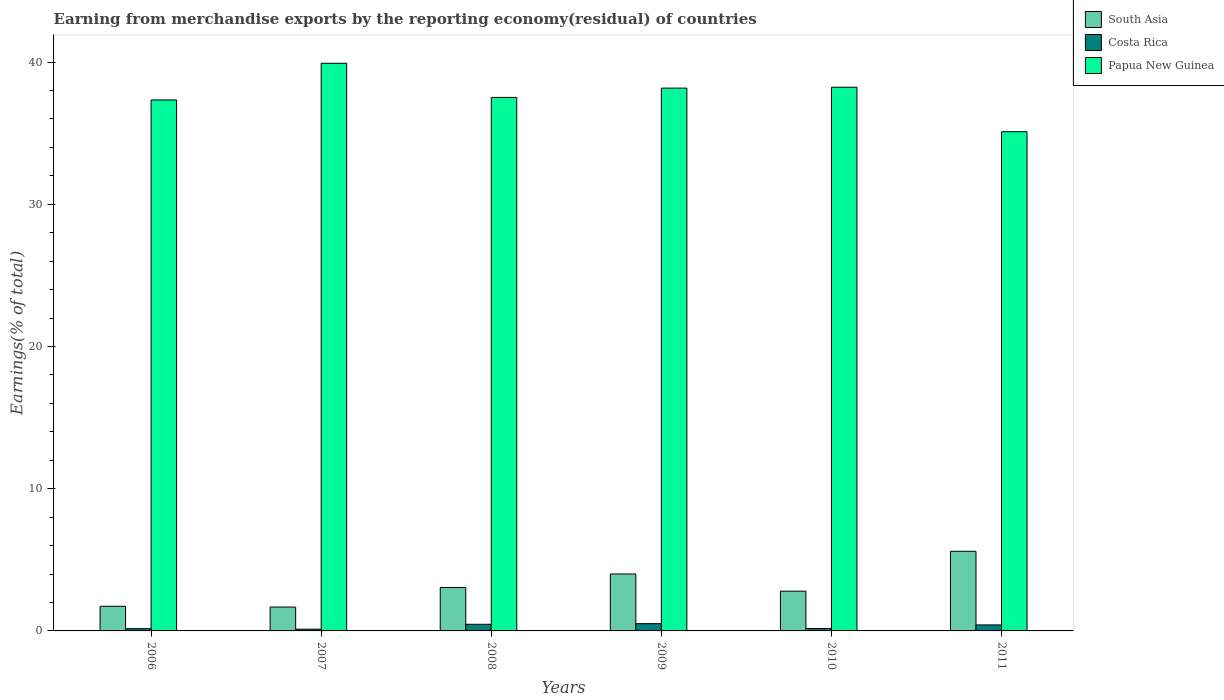How many different coloured bars are there?
Your answer should be very brief. 3. Are the number of bars per tick equal to the number of legend labels?
Your response must be concise. Yes. What is the label of the 3rd group of bars from the left?
Keep it short and to the point. 2008. What is the percentage of amount earned from merchandise exports in Costa Rica in 2006?
Ensure brevity in your answer.  0.16. Across all years, what is the maximum percentage of amount earned from merchandise exports in Costa Rica?
Your answer should be very brief. 0.51. Across all years, what is the minimum percentage of amount earned from merchandise exports in Papua New Guinea?
Provide a succinct answer. 35.1. In which year was the percentage of amount earned from merchandise exports in South Asia maximum?
Offer a very short reply. 2011. In which year was the percentage of amount earned from merchandise exports in Papua New Guinea minimum?
Your answer should be compact. 2011. What is the total percentage of amount earned from merchandise exports in Papua New Guinea in the graph?
Offer a terse response. 226.26. What is the difference between the percentage of amount earned from merchandise exports in Papua New Guinea in 2006 and that in 2007?
Your answer should be compact. -2.58. What is the difference between the percentage of amount earned from merchandise exports in South Asia in 2007 and the percentage of amount earned from merchandise exports in Papua New Guinea in 2009?
Your response must be concise. -36.49. What is the average percentage of amount earned from merchandise exports in Costa Rica per year?
Ensure brevity in your answer.  0.31. In the year 2007, what is the difference between the percentage of amount earned from merchandise exports in South Asia and percentage of amount earned from merchandise exports in Papua New Guinea?
Give a very brief answer. -38.24. In how many years, is the percentage of amount earned from merchandise exports in Papua New Guinea greater than 4 %?
Ensure brevity in your answer.  6. What is the ratio of the percentage of amount earned from merchandise exports in South Asia in 2007 to that in 2010?
Your answer should be compact. 0.6. Is the percentage of amount earned from merchandise exports in Costa Rica in 2009 less than that in 2010?
Your answer should be very brief. No. What is the difference between the highest and the second highest percentage of amount earned from merchandise exports in South Asia?
Ensure brevity in your answer.  1.6. What is the difference between the highest and the lowest percentage of amount earned from merchandise exports in South Asia?
Make the answer very short. 3.92. Is the sum of the percentage of amount earned from merchandise exports in Costa Rica in 2007 and 2009 greater than the maximum percentage of amount earned from merchandise exports in Papua New Guinea across all years?
Your response must be concise. No. What does the 3rd bar from the right in 2011 represents?
Provide a short and direct response. South Asia. How many years are there in the graph?
Your answer should be very brief. 6. Are the values on the major ticks of Y-axis written in scientific E-notation?
Give a very brief answer. No. Does the graph contain grids?
Provide a short and direct response. No. How are the legend labels stacked?
Provide a succinct answer. Vertical. What is the title of the graph?
Offer a very short reply. Earning from merchandise exports by the reporting economy(residual) of countries. What is the label or title of the X-axis?
Make the answer very short. Years. What is the label or title of the Y-axis?
Your response must be concise. Earnings(% of total). What is the Earnings(% of total) of South Asia in 2006?
Offer a very short reply. 1.73. What is the Earnings(% of total) in Costa Rica in 2006?
Ensure brevity in your answer.  0.16. What is the Earnings(% of total) of Papua New Guinea in 2006?
Make the answer very short. 37.34. What is the Earnings(% of total) in South Asia in 2007?
Offer a very short reply. 1.68. What is the Earnings(% of total) of Costa Rica in 2007?
Offer a terse response. 0.12. What is the Earnings(% of total) in Papua New Guinea in 2007?
Your response must be concise. 39.91. What is the Earnings(% of total) in South Asia in 2008?
Your response must be concise. 3.05. What is the Earnings(% of total) of Costa Rica in 2008?
Ensure brevity in your answer.  0.47. What is the Earnings(% of total) of Papua New Guinea in 2008?
Offer a terse response. 37.51. What is the Earnings(% of total) of South Asia in 2009?
Offer a terse response. 4. What is the Earnings(% of total) of Costa Rica in 2009?
Your answer should be very brief. 0.51. What is the Earnings(% of total) of Papua New Guinea in 2009?
Your response must be concise. 38.17. What is the Earnings(% of total) of South Asia in 2010?
Offer a terse response. 2.8. What is the Earnings(% of total) of Costa Rica in 2010?
Ensure brevity in your answer.  0.17. What is the Earnings(% of total) in Papua New Guinea in 2010?
Provide a short and direct response. 38.23. What is the Earnings(% of total) in South Asia in 2011?
Provide a short and direct response. 5.6. What is the Earnings(% of total) of Costa Rica in 2011?
Provide a short and direct response. 0.42. What is the Earnings(% of total) of Papua New Guinea in 2011?
Offer a terse response. 35.1. Across all years, what is the maximum Earnings(% of total) in South Asia?
Give a very brief answer. 5.6. Across all years, what is the maximum Earnings(% of total) in Costa Rica?
Make the answer very short. 0.51. Across all years, what is the maximum Earnings(% of total) of Papua New Guinea?
Your answer should be very brief. 39.91. Across all years, what is the minimum Earnings(% of total) of South Asia?
Your answer should be compact. 1.68. Across all years, what is the minimum Earnings(% of total) in Costa Rica?
Your answer should be very brief. 0.12. Across all years, what is the minimum Earnings(% of total) in Papua New Guinea?
Your response must be concise. 35.1. What is the total Earnings(% of total) in South Asia in the graph?
Give a very brief answer. 18.86. What is the total Earnings(% of total) in Costa Rica in the graph?
Provide a succinct answer. 1.85. What is the total Earnings(% of total) of Papua New Guinea in the graph?
Your answer should be very brief. 226.26. What is the difference between the Earnings(% of total) in South Asia in 2006 and that in 2007?
Your answer should be compact. 0.05. What is the difference between the Earnings(% of total) of Costa Rica in 2006 and that in 2007?
Offer a terse response. 0.04. What is the difference between the Earnings(% of total) in Papua New Guinea in 2006 and that in 2007?
Your response must be concise. -2.58. What is the difference between the Earnings(% of total) in South Asia in 2006 and that in 2008?
Make the answer very short. -1.32. What is the difference between the Earnings(% of total) in Costa Rica in 2006 and that in 2008?
Ensure brevity in your answer.  -0.31. What is the difference between the Earnings(% of total) of Papua New Guinea in 2006 and that in 2008?
Give a very brief answer. -0.18. What is the difference between the Earnings(% of total) of South Asia in 2006 and that in 2009?
Give a very brief answer. -2.27. What is the difference between the Earnings(% of total) in Costa Rica in 2006 and that in 2009?
Offer a terse response. -0.35. What is the difference between the Earnings(% of total) in Papua New Guinea in 2006 and that in 2009?
Keep it short and to the point. -0.83. What is the difference between the Earnings(% of total) of South Asia in 2006 and that in 2010?
Your response must be concise. -1.06. What is the difference between the Earnings(% of total) of Costa Rica in 2006 and that in 2010?
Offer a very short reply. -0.01. What is the difference between the Earnings(% of total) in Papua New Guinea in 2006 and that in 2010?
Keep it short and to the point. -0.89. What is the difference between the Earnings(% of total) of South Asia in 2006 and that in 2011?
Make the answer very short. -3.87. What is the difference between the Earnings(% of total) in Costa Rica in 2006 and that in 2011?
Your answer should be very brief. -0.26. What is the difference between the Earnings(% of total) of Papua New Guinea in 2006 and that in 2011?
Your answer should be compact. 2.23. What is the difference between the Earnings(% of total) of South Asia in 2007 and that in 2008?
Your answer should be compact. -1.38. What is the difference between the Earnings(% of total) of Costa Rica in 2007 and that in 2008?
Keep it short and to the point. -0.35. What is the difference between the Earnings(% of total) of Papua New Guinea in 2007 and that in 2008?
Provide a short and direct response. 2.4. What is the difference between the Earnings(% of total) of South Asia in 2007 and that in 2009?
Keep it short and to the point. -2.32. What is the difference between the Earnings(% of total) in Costa Rica in 2007 and that in 2009?
Keep it short and to the point. -0.39. What is the difference between the Earnings(% of total) of Papua New Guinea in 2007 and that in 2009?
Keep it short and to the point. 1.75. What is the difference between the Earnings(% of total) of South Asia in 2007 and that in 2010?
Your answer should be compact. -1.12. What is the difference between the Earnings(% of total) in Costa Rica in 2007 and that in 2010?
Give a very brief answer. -0.05. What is the difference between the Earnings(% of total) of Papua New Guinea in 2007 and that in 2010?
Give a very brief answer. 1.68. What is the difference between the Earnings(% of total) of South Asia in 2007 and that in 2011?
Offer a very short reply. -3.92. What is the difference between the Earnings(% of total) in Costa Rica in 2007 and that in 2011?
Your response must be concise. -0.3. What is the difference between the Earnings(% of total) in Papua New Guinea in 2007 and that in 2011?
Your answer should be compact. 4.81. What is the difference between the Earnings(% of total) of South Asia in 2008 and that in 2009?
Keep it short and to the point. -0.95. What is the difference between the Earnings(% of total) in Costa Rica in 2008 and that in 2009?
Your answer should be compact. -0.04. What is the difference between the Earnings(% of total) of Papua New Guinea in 2008 and that in 2009?
Provide a succinct answer. -0.65. What is the difference between the Earnings(% of total) in South Asia in 2008 and that in 2010?
Keep it short and to the point. 0.26. What is the difference between the Earnings(% of total) in Costa Rica in 2008 and that in 2010?
Provide a succinct answer. 0.3. What is the difference between the Earnings(% of total) in Papua New Guinea in 2008 and that in 2010?
Ensure brevity in your answer.  -0.72. What is the difference between the Earnings(% of total) in South Asia in 2008 and that in 2011?
Offer a very short reply. -2.55. What is the difference between the Earnings(% of total) in Costa Rica in 2008 and that in 2011?
Provide a succinct answer. 0.04. What is the difference between the Earnings(% of total) in Papua New Guinea in 2008 and that in 2011?
Offer a very short reply. 2.41. What is the difference between the Earnings(% of total) of South Asia in 2009 and that in 2010?
Provide a succinct answer. 1.21. What is the difference between the Earnings(% of total) of Costa Rica in 2009 and that in 2010?
Provide a succinct answer. 0.34. What is the difference between the Earnings(% of total) in Papua New Guinea in 2009 and that in 2010?
Make the answer very short. -0.06. What is the difference between the Earnings(% of total) in South Asia in 2009 and that in 2011?
Provide a succinct answer. -1.6. What is the difference between the Earnings(% of total) of Costa Rica in 2009 and that in 2011?
Your response must be concise. 0.09. What is the difference between the Earnings(% of total) in Papua New Guinea in 2009 and that in 2011?
Offer a very short reply. 3.06. What is the difference between the Earnings(% of total) of South Asia in 2010 and that in 2011?
Ensure brevity in your answer.  -2.8. What is the difference between the Earnings(% of total) of Costa Rica in 2010 and that in 2011?
Give a very brief answer. -0.25. What is the difference between the Earnings(% of total) in Papua New Guinea in 2010 and that in 2011?
Your response must be concise. 3.13. What is the difference between the Earnings(% of total) in South Asia in 2006 and the Earnings(% of total) in Costa Rica in 2007?
Ensure brevity in your answer.  1.61. What is the difference between the Earnings(% of total) of South Asia in 2006 and the Earnings(% of total) of Papua New Guinea in 2007?
Offer a terse response. -38.18. What is the difference between the Earnings(% of total) in Costa Rica in 2006 and the Earnings(% of total) in Papua New Guinea in 2007?
Keep it short and to the point. -39.75. What is the difference between the Earnings(% of total) of South Asia in 2006 and the Earnings(% of total) of Costa Rica in 2008?
Offer a very short reply. 1.27. What is the difference between the Earnings(% of total) in South Asia in 2006 and the Earnings(% of total) in Papua New Guinea in 2008?
Give a very brief answer. -35.78. What is the difference between the Earnings(% of total) in Costa Rica in 2006 and the Earnings(% of total) in Papua New Guinea in 2008?
Provide a succinct answer. -37.35. What is the difference between the Earnings(% of total) of South Asia in 2006 and the Earnings(% of total) of Costa Rica in 2009?
Keep it short and to the point. 1.22. What is the difference between the Earnings(% of total) in South Asia in 2006 and the Earnings(% of total) in Papua New Guinea in 2009?
Make the answer very short. -36.43. What is the difference between the Earnings(% of total) of Costa Rica in 2006 and the Earnings(% of total) of Papua New Guinea in 2009?
Your answer should be very brief. -38.01. What is the difference between the Earnings(% of total) of South Asia in 2006 and the Earnings(% of total) of Costa Rica in 2010?
Offer a terse response. 1.56. What is the difference between the Earnings(% of total) of South Asia in 2006 and the Earnings(% of total) of Papua New Guinea in 2010?
Your response must be concise. -36.5. What is the difference between the Earnings(% of total) of Costa Rica in 2006 and the Earnings(% of total) of Papua New Guinea in 2010?
Keep it short and to the point. -38.07. What is the difference between the Earnings(% of total) of South Asia in 2006 and the Earnings(% of total) of Costa Rica in 2011?
Your response must be concise. 1.31. What is the difference between the Earnings(% of total) in South Asia in 2006 and the Earnings(% of total) in Papua New Guinea in 2011?
Give a very brief answer. -33.37. What is the difference between the Earnings(% of total) of Costa Rica in 2006 and the Earnings(% of total) of Papua New Guinea in 2011?
Keep it short and to the point. -34.94. What is the difference between the Earnings(% of total) of South Asia in 2007 and the Earnings(% of total) of Costa Rica in 2008?
Offer a terse response. 1.21. What is the difference between the Earnings(% of total) of South Asia in 2007 and the Earnings(% of total) of Papua New Guinea in 2008?
Offer a terse response. -35.83. What is the difference between the Earnings(% of total) in Costa Rica in 2007 and the Earnings(% of total) in Papua New Guinea in 2008?
Provide a succinct answer. -37.39. What is the difference between the Earnings(% of total) of South Asia in 2007 and the Earnings(% of total) of Costa Rica in 2009?
Give a very brief answer. 1.17. What is the difference between the Earnings(% of total) in South Asia in 2007 and the Earnings(% of total) in Papua New Guinea in 2009?
Offer a very short reply. -36.49. What is the difference between the Earnings(% of total) in Costa Rica in 2007 and the Earnings(% of total) in Papua New Guinea in 2009?
Ensure brevity in your answer.  -38.05. What is the difference between the Earnings(% of total) of South Asia in 2007 and the Earnings(% of total) of Costa Rica in 2010?
Offer a terse response. 1.51. What is the difference between the Earnings(% of total) of South Asia in 2007 and the Earnings(% of total) of Papua New Guinea in 2010?
Provide a succinct answer. -36.55. What is the difference between the Earnings(% of total) in Costa Rica in 2007 and the Earnings(% of total) in Papua New Guinea in 2010?
Your answer should be very brief. -38.11. What is the difference between the Earnings(% of total) in South Asia in 2007 and the Earnings(% of total) in Costa Rica in 2011?
Provide a short and direct response. 1.26. What is the difference between the Earnings(% of total) of South Asia in 2007 and the Earnings(% of total) of Papua New Guinea in 2011?
Offer a very short reply. -33.42. What is the difference between the Earnings(% of total) of Costa Rica in 2007 and the Earnings(% of total) of Papua New Guinea in 2011?
Provide a short and direct response. -34.98. What is the difference between the Earnings(% of total) in South Asia in 2008 and the Earnings(% of total) in Costa Rica in 2009?
Your answer should be very brief. 2.54. What is the difference between the Earnings(% of total) in South Asia in 2008 and the Earnings(% of total) in Papua New Guinea in 2009?
Your answer should be very brief. -35.11. What is the difference between the Earnings(% of total) of Costa Rica in 2008 and the Earnings(% of total) of Papua New Guinea in 2009?
Provide a succinct answer. -37.7. What is the difference between the Earnings(% of total) of South Asia in 2008 and the Earnings(% of total) of Costa Rica in 2010?
Give a very brief answer. 2.89. What is the difference between the Earnings(% of total) of South Asia in 2008 and the Earnings(% of total) of Papua New Guinea in 2010?
Give a very brief answer. -35.17. What is the difference between the Earnings(% of total) of Costa Rica in 2008 and the Earnings(% of total) of Papua New Guinea in 2010?
Ensure brevity in your answer.  -37.76. What is the difference between the Earnings(% of total) of South Asia in 2008 and the Earnings(% of total) of Costa Rica in 2011?
Make the answer very short. 2.63. What is the difference between the Earnings(% of total) in South Asia in 2008 and the Earnings(% of total) in Papua New Guinea in 2011?
Provide a succinct answer. -32.05. What is the difference between the Earnings(% of total) of Costa Rica in 2008 and the Earnings(% of total) of Papua New Guinea in 2011?
Offer a very short reply. -34.64. What is the difference between the Earnings(% of total) of South Asia in 2009 and the Earnings(% of total) of Costa Rica in 2010?
Your answer should be compact. 3.83. What is the difference between the Earnings(% of total) of South Asia in 2009 and the Earnings(% of total) of Papua New Guinea in 2010?
Ensure brevity in your answer.  -34.23. What is the difference between the Earnings(% of total) of Costa Rica in 2009 and the Earnings(% of total) of Papua New Guinea in 2010?
Offer a very short reply. -37.72. What is the difference between the Earnings(% of total) of South Asia in 2009 and the Earnings(% of total) of Costa Rica in 2011?
Your response must be concise. 3.58. What is the difference between the Earnings(% of total) of South Asia in 2009 and the Earnings(% of total) of Papua New Guinea in 2011?
Offer a very short reply. -31.1. What is the difference between the Earnings(% of total) of Costa Rica in 2009 and the Earnings(% of total) of Papua New Guinea in 2011?
Offer a very short reply. -34.59. What is the difference between the Earnings(% of total) of South Asia in 2010 and the Earnings(% of total) of Costa Rica in 2011?
Make the answer very short. 2.37. What is the difference between the Earnings(% of total) in South Asia in 2010 and the Earnings(% of total) in Papua New Guinea in 2011?
Ensure brevity in your answer.  -32.31. What is the difference between the Earnings(% of total) in Costa Rica in 2010 and the Earnings(% of total) in Papua New Guinea in 2011?
Your response must be concise. -34.93. What is the average Earnings(% of total) of South Asia per year?
Ensure brevity in your answer.  3.14. What is the average Earnings(% of total) of Costa Rica per year?
Your answer should be compact. 0.31. What is the average Earnings(% of total) in Papua New Guinea per year?
Keep it short and to the point. 37.71. In the year 2006, what is the difference between the Earnings(% of total) in South Asia and Earnings(% of total) in Costa Rica?
Give a very brief answer. 1.57. In the year 2006, what is the difference between the Earnings(% of total) of South Asia and Earnings(% of total) of Papua New Guinea?
Your response must be concise. -35.6. In the year 2006, what is the difference between the Earnings(% of total) of Costa Rica and Earnings(% of total) of Papua New Guinea?
Provide a succinct answer. -37.18. In the year 2007, what is the difference between the Earnings(% of total) in South Asia and Earnings(% of total) in Costa Rica?
Your answer should be very brief. 1.56. In the year 2007, what is the difference between the Earnings(% of total) of South Asia and Earnings(% of total) of Papua New Guinea?
Make the answer very short. -38.24. In the year 2007, what is the difference between the Earnings(% of total) in Costa Rica and Earnings(% of total) in Papua New Guinea?
Give a very brief answer. -39.79. In the year 2008, what is the difference between the Earnings(% of total) in South Asia and Earnings(% of total) in Costa Rica?
Provide a succinct answer. 2.59. In the year 2008, what is the difference between the Earnings(% of total) of South Asia and Earnings(% of total) of Papua New Guinea?
Keep it short and to the point. -34.46. In the year 2008, what is the difference between the Earnings(% of total) in Costa Rica and Earnings(% of total) in Papua New Guinea?
Provide a short and direct response. -37.05. In the year 2009, what is the difference between the Earnings(% of total) of South Asia and Earnings(% of total) of Costa Rica?
Provide a short and direct response. 3.49. In the year 2009, what is the difference between the Earnings(% of total) in South Asia and Earnings(% of total) in Papua New Guinea?
Ensure brevity in your answer.  -34.16. In the year 2009, what is the difference between the Earnings(% of total) in Costa Rica and Earnings(% of total) in Papua New Guinea?
Offer a terse response. -37.66. In the year 2010, what is the difference between the Earnings(% of total) in South Asia and Earnings(% of total) in Costa Rica?
Give a very brief answer. 2.63. In the year 2010, what is the difference between the Earnings(% of total) of South Asia and Earnings(% of total) of Papua New Guinea?
Your response must be concise. -35.43. In the year 2010, what is the difference between the Earnings(% of total) in Costa Rica and Earnings(% of total) in Papua New Guinea?
Provide a succinct answer. -38.06. In the year 2011, what is the difference between the Earnings(% of total) in South Asia and Earnings(% of total) in Costa Rica?
Make the answer very short. 5.18. In the year 2011, what is the difference between the Earnings(% of total) in South Asia and Earnings(% of total) in Papua New Guinea?
Offer a very short reply. -29.5. In the year 2011, what is the difference between the Earnings(% of total) of Costa Rica and Earnings(% of total) of Papua New Guinea?
Your answer should be compact. -34.68. What is the ratio of the Earnings(% of total) of South Asia in 2006 to that in 2007?
Your answer should be compact. 1.03. What is the ratio of the Earnings(% of total) in Costa Rica in 2006 to that in 2007?
Ensure brevity in your answer.  1.32. What is the ratio of the Earnings(% of total) of Papua New Guinea in 2006 to that in 2007?
Provide a succinct answer. 0.94. What is the ratio of the Earnings(% of total) of South Asia in 2006 to that in 2008?
Provide a short and direct response. 0.57. What is the ratio of the Earnings(% of total) in Costa Rica in 2006 to that in 2008?
Your answer should be compact. 0.34. What is the ratio of the Earnings(% of total) in Papua New Guinea in 2006 to that in 2008?
Provide a short and direct response. 1. What is the ratio of the Earnings(% of total) in South Asia in 2006 to that in 2009?
Keep it short and to the point. 0.43. What is the ratio of the Earnings(% of total) in Costa Rica in 2006 to that in 2009?
Make the answer very short. 0.31. What is the ratio of the Earnings(% of total) in Papua New Guinea in 2006 to that in 2009?
Offer a very short reply. 0.98. What is the ratio of the Earnings(% of total) in South Asia in 2006 to that in 2010?
Offer a very short reply. 0.62. What is the ratio of the Earnings(% of total) of Costa Rica in 2006 to that in 2010?
Your answer should be very brief. 0.95. What is the ratio of the Earnings(% of total) of Papua New Guinea in 2006 to that in 2010?
Keep it short and to the point. 0.98. What is the ratio of the Earnings(% of total) in South Asia in 2006 to that in 2011?
Provide a short and direct response. 0.31. What is the ratio of the Earnings(% of total) of Costa Rica in 2006 to that in 2011?
Provide a short and direct response. 0.38. What is the ratio of the Earnings(% of total) in Papua New Guinea in 2006 to that in 2011?
Ensure brevity in your answer.  1.06. What is the ratio of the Earnings(% of total) of South Asia in 2007 to that in 2008?
Offer a very short reply. 0.55. What is the ratio of the Earnings(% of total) in Costa Rica in 2007 to that in 2008?
Your answer should be very brief. 0.26. What is the ratio of the Earnings(% of total) of Papua New Guinea in 2007 to that in 2008?
Ensure brevity in your answer.  1.06. What is the ratio of the Earnings(% of total) in South Asia in 2007 to that in 2009?
Offer a terse response. 0.42. What is the ratio of the Earnings(% of total) of Costa Rica in 2007 to that in 2009?
Offer a very short reply. 0.24. What is the ratio of the Earnings(% of total) of Papua New Guinea in 2007 to that in 2009?
Your answer should be very brief. 1.05. What is the ratio of the Earnings(% of total) in South Asia in 2007 to that in 2010?
Your answer should be very brief. 0.6. What is the ratio of the Earnings(% of total) in Costa Rica in 2007 to that in 2010?
Your response must be concise. 0.72. What is the ratio of the Earnings(% of total) of Papua New Guinea in 2007 to that in 2010?
Ensure brevity in your answer.  1.04. What is the ratio of the Earnings(% of total) of South Asia in 2007 to that in 2011?
Make the answer very short. 0.3. What is the ratio of the Earnings(% of total) of Costa Rica in 2007 to that in 2011?
Your answer should be very brief. 0.29. What is the ratio of the Earnings(% of total) in Papua New Guinea in 2007 to that in 2011?
Keep it short and to the point. 1.14. What is the ratio of the Earnings(% of total) in South Asia in 2008 to that in 2009?
Give a very brief answer. 0.76. What is the ratio of the Earnings(% of total) of Costa Rica in 2008 to that in 2009?
Your answer should be very brief. 0.91. What is the ratio of the Earnings(% of total) of Papua New Guinea in 2008 to that in 2009?
Make the answer very short. 0.98. What is the ratio of the Earnings(% of total) of South Asia in 2008 to that in 2010?
Give a very brief answer. 1.09. What is the ratio of the Earnings(% of total) of Costa Rica in 2008 to that in 2010?
Your answer should be compact. 2.77. What is the ratio of the Earnings(% of total) of Papua New Guinea in 2008 to that in 2010?
Keep it short and to the point. 0.98. What is the ratio of the Earnings(% of total) of South Asia in 2008 to that in 2011?
Provide a succinct answer. 0.55. What is the ratio of the Earnings(% of total) of Costa Rica in 2008 to that in 2011?
Offer a terse response. 1.1. What is the ratio of the Earnings(% of total) in Papua New Guinea in 2008 to that in 2011?
Provide a short and direct response. 1.07. What is the ratio of the Earnings(% of total) in South Asia in 2009 to that in 2010?
Ensure brevity in your answer.  1.43. What is the ratio of the Earnings(% of total) of Costa Rica in 2009 to that in 2010?
Offer a terse response. 3.03. What is the ratio of the Earnings(% of total) of Papua New Guinea in 2009 to that in 2010?
Make the answer very short. 1. What is the ratio of the Earnings(% of total) in South Asia in 2009 to that in 2011?
Your answer should be compact. 0.71. What is the ratio of the Earnings(% of total) in Costa Rica in 2009 to that in 2011?
Make the answer very short. 1.21. What is the ratio of the Earnings(% of total) of Papua New Guinea in 2009 to that in 2011?
Make the answer very short. 1.09. What is the ratio of the Earnings(% of total) of South Asia in 2010 to that in 2011?
Your response must be concise. 0.5. What is the ratio of the Earnings(% of total) of Costa Rica in 2010 to that in 2011?
Keep it short and to the point. 0.4. What is the ratio of the Earnings(% of total) in Papua New Guinea in 2010 to that in 2011?
Offer a very short reply. 1.09. What is the difference between the highest and the second highest Earnings(% of total) in South Asia?
Your answer should be very brief. 1.6. What is the difference between the highest and the second highest Earnings(% of total) of Costa Rica?
Make the answer very short. 0.04. What is the difference between the highest and the second highest Earnings(% of total) in Papua New Guinea?
Your answer should be compact. 1.68. What is the difference between the highest and the lowest Earnings(% of total) in South Asia?
Your answer should be compact. 3.92. What is the difference between the highest and the lowest Earnings(% of total) of Costa Rica?
Give a very brief answer. 0.39. What is the difference between the highest and the lowest Earnings(% of total) of Papua New Guinea?
Your response must be concise. 4.81. 